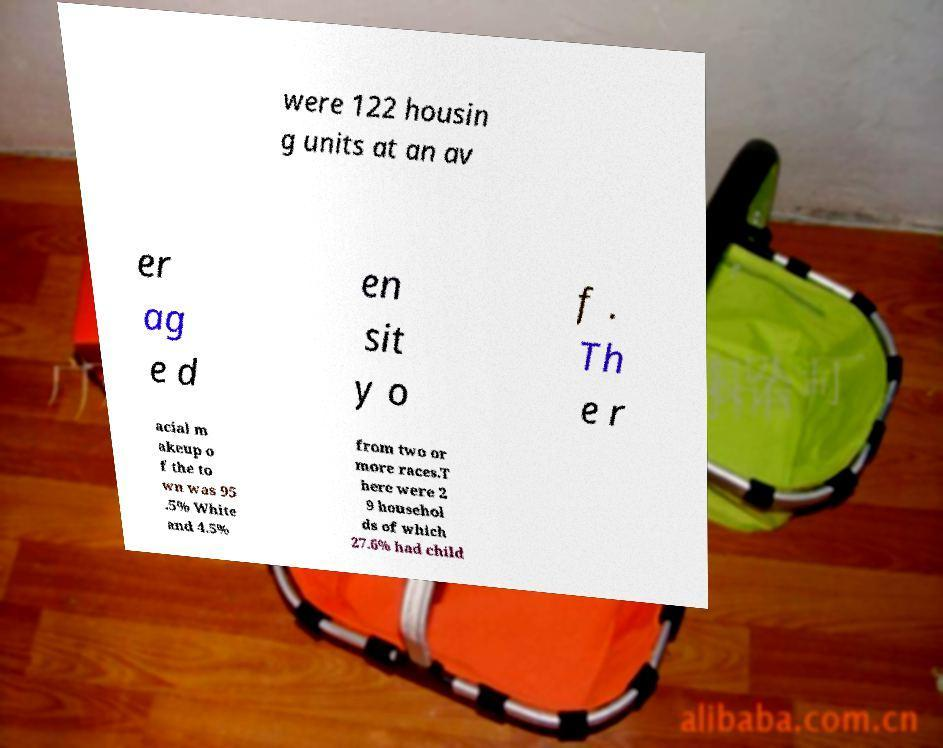Can you read and provide the text displayed in the image?This photo seems to have some interesting text. Can you extract and type it out for me? were 122 housin g units at an av er ag e d en sit y o f . Th e r acial m akeup o f the to wn was 95 .5% White and 4.5% from two or more races.T here were 2 9 househol ds of which 27.6% had child 